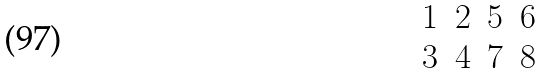<formula> <loc_0><loc_0><loc_500><loc_500>\begin{matrix} 1 & 2 & 5 & 6 \\ 3 & 4 & 7 & 8 \\ \end{matrix}</formula> 